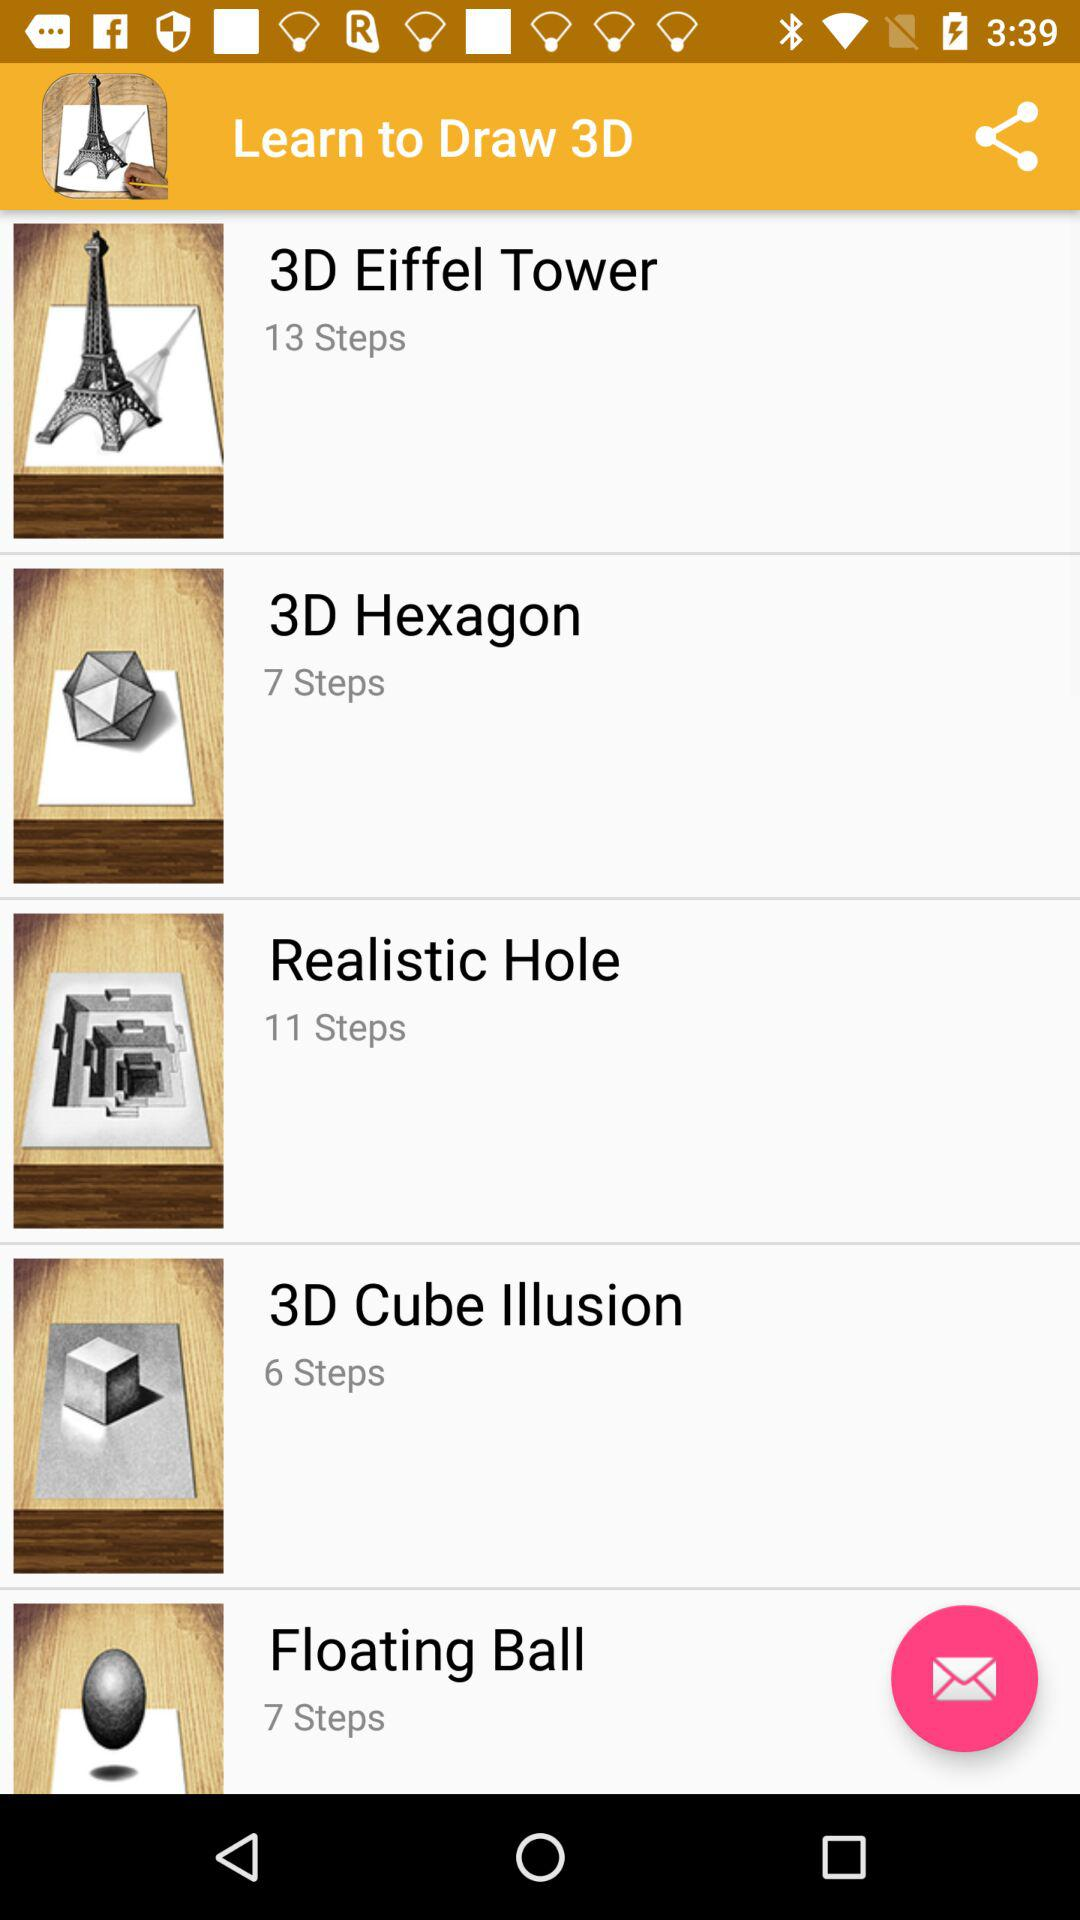How many steps are there in the object with the least number of steps?
Answer the question using a single word or phrase. 6 